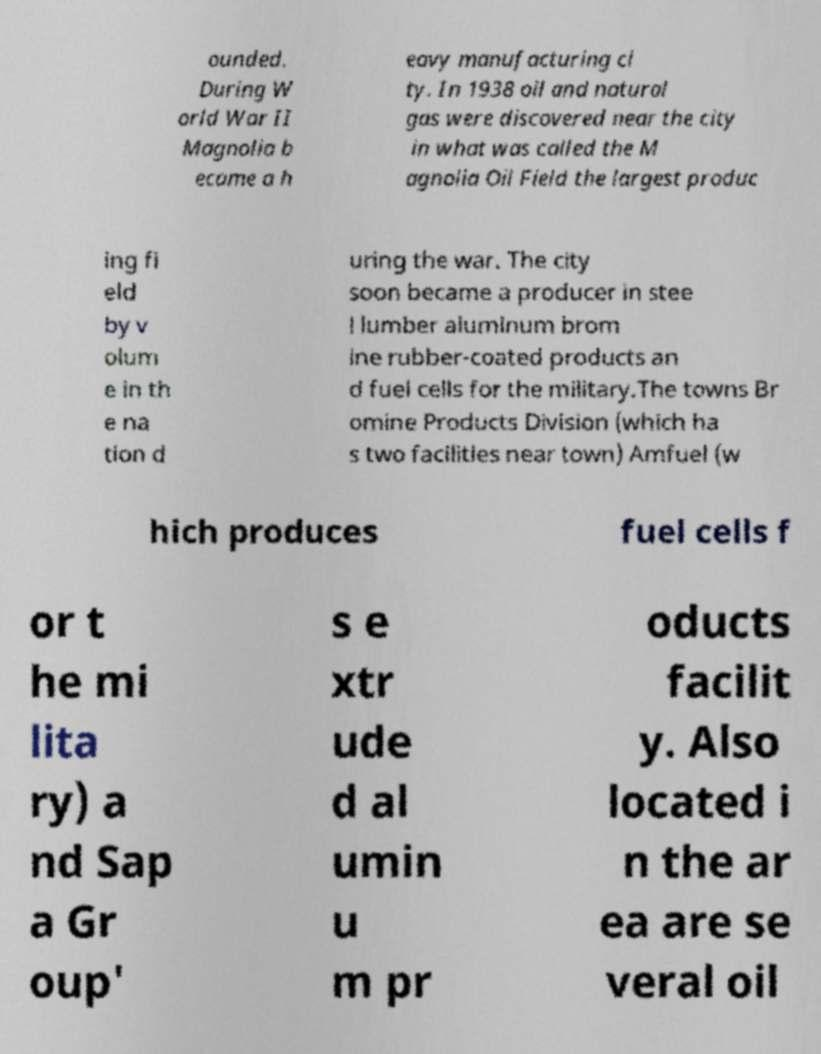Could you extract and type out the text from this image? ounded. During W orld War II Magnolia b ecame a h eavy manufacturing ci ty. In 1938 oil and natural gas were discovered near the city in what was called the M agnolia Oil Field the largest produc ing fi eld by v olum e in th e na tion d uring the war. The city soon became a producer in stee l lumber aluminum brom ine rubber-coated products an d fuel cells for the military.The towns Br omine Products Division (which ha s two facilities near town) Amfuel (w hich produces fuel cells f or t he mi lita ry) a nd Sap a Gr oup' s e xtr ude d al umin u m pr oducts facilit y. Also located i n the ar ea are se veral oil 